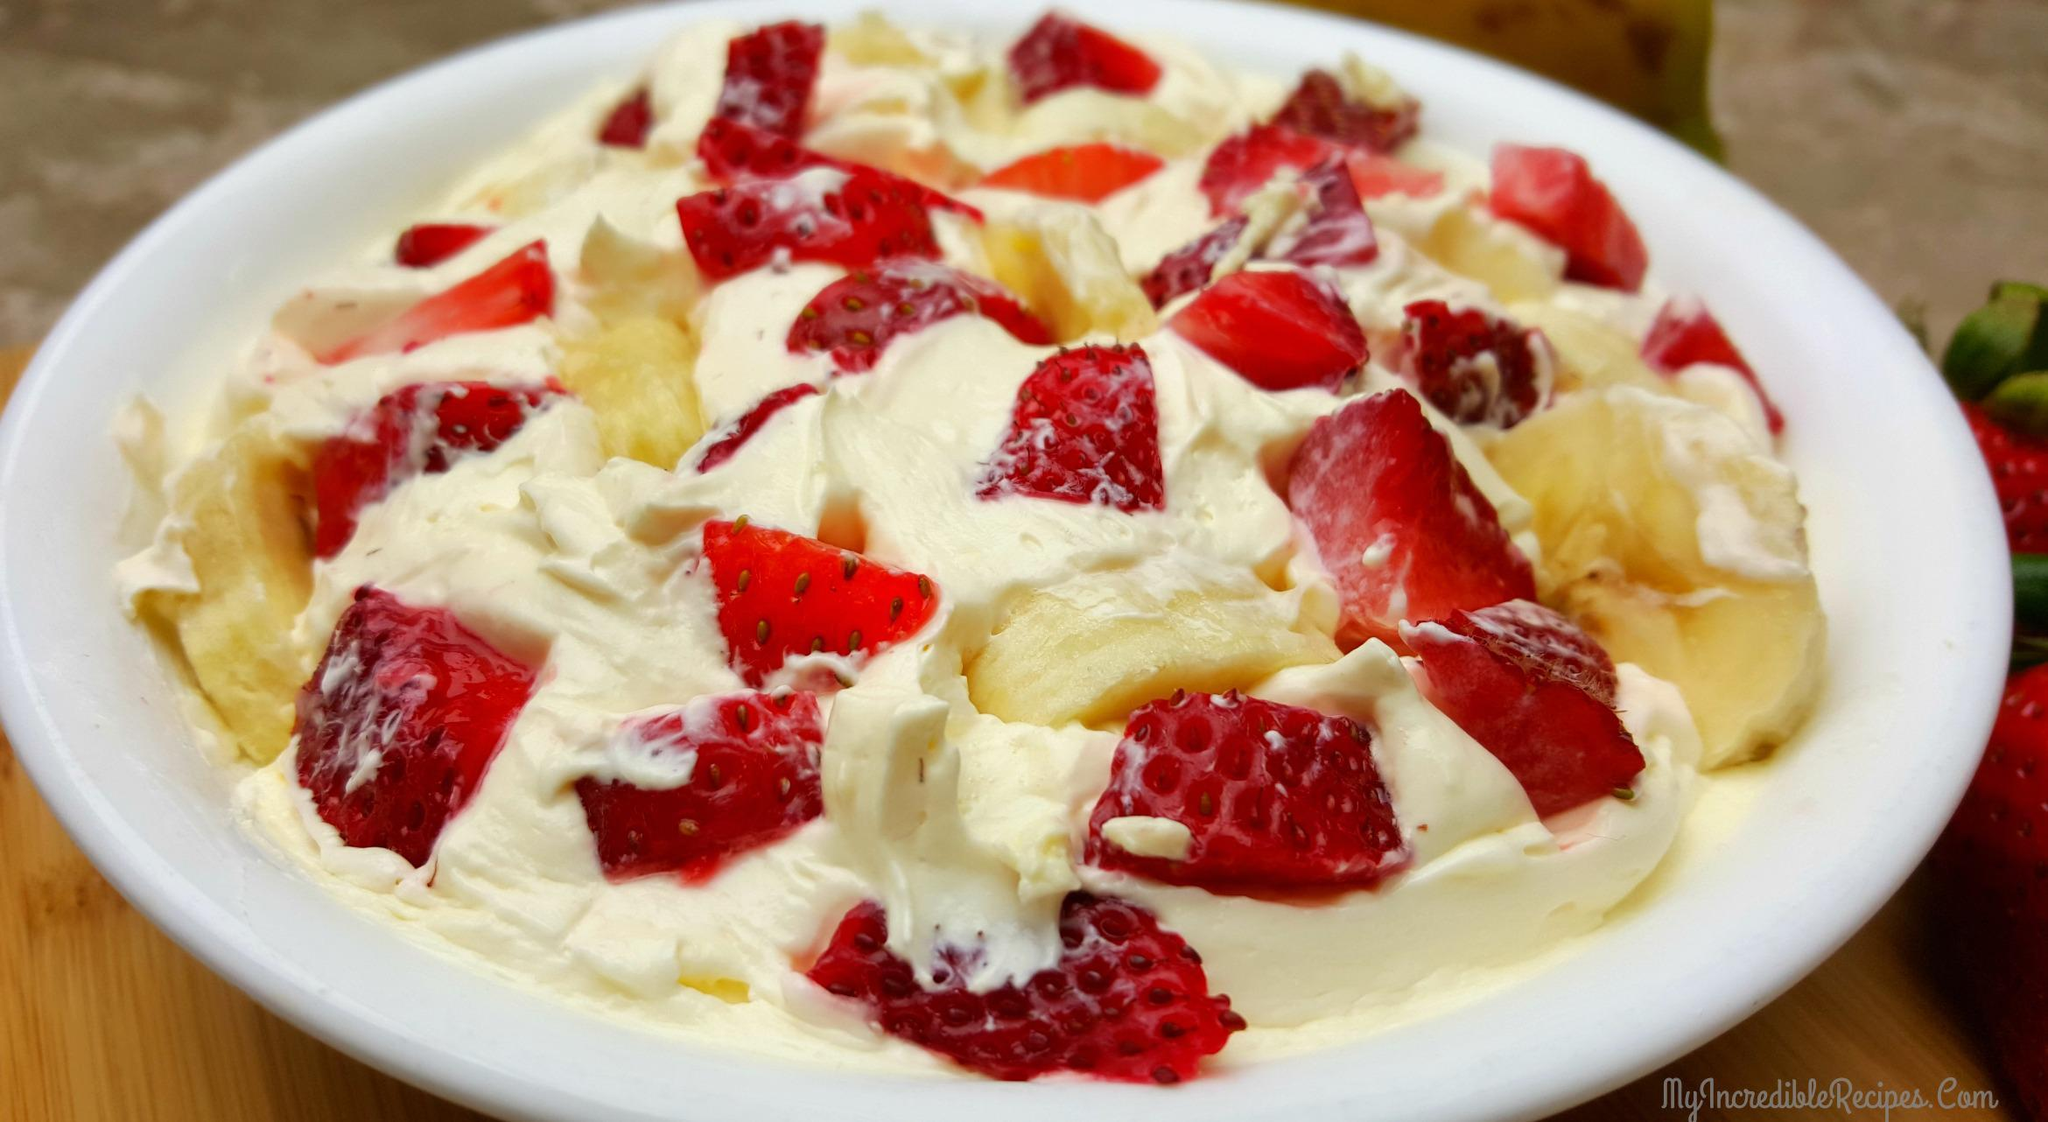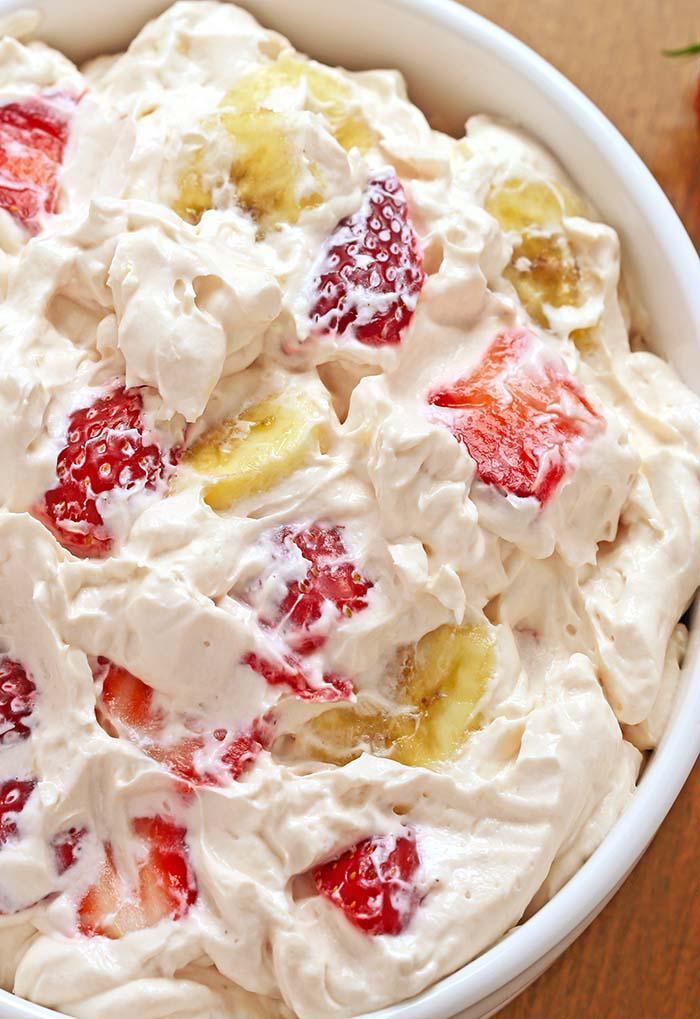The first image is the image on the left, the second image is the image on the right. Given the left and right images, does the statement "There is an eating utensil next to a bowl of fruit salad." hold true? Answer yes or no. No. The first image is the image on the left, the second image is the image on the right. Considering the images on both sides, is "An image shows a bowl topped with strawberry and a green leafy spring." valid? Answer yes or no. No. 